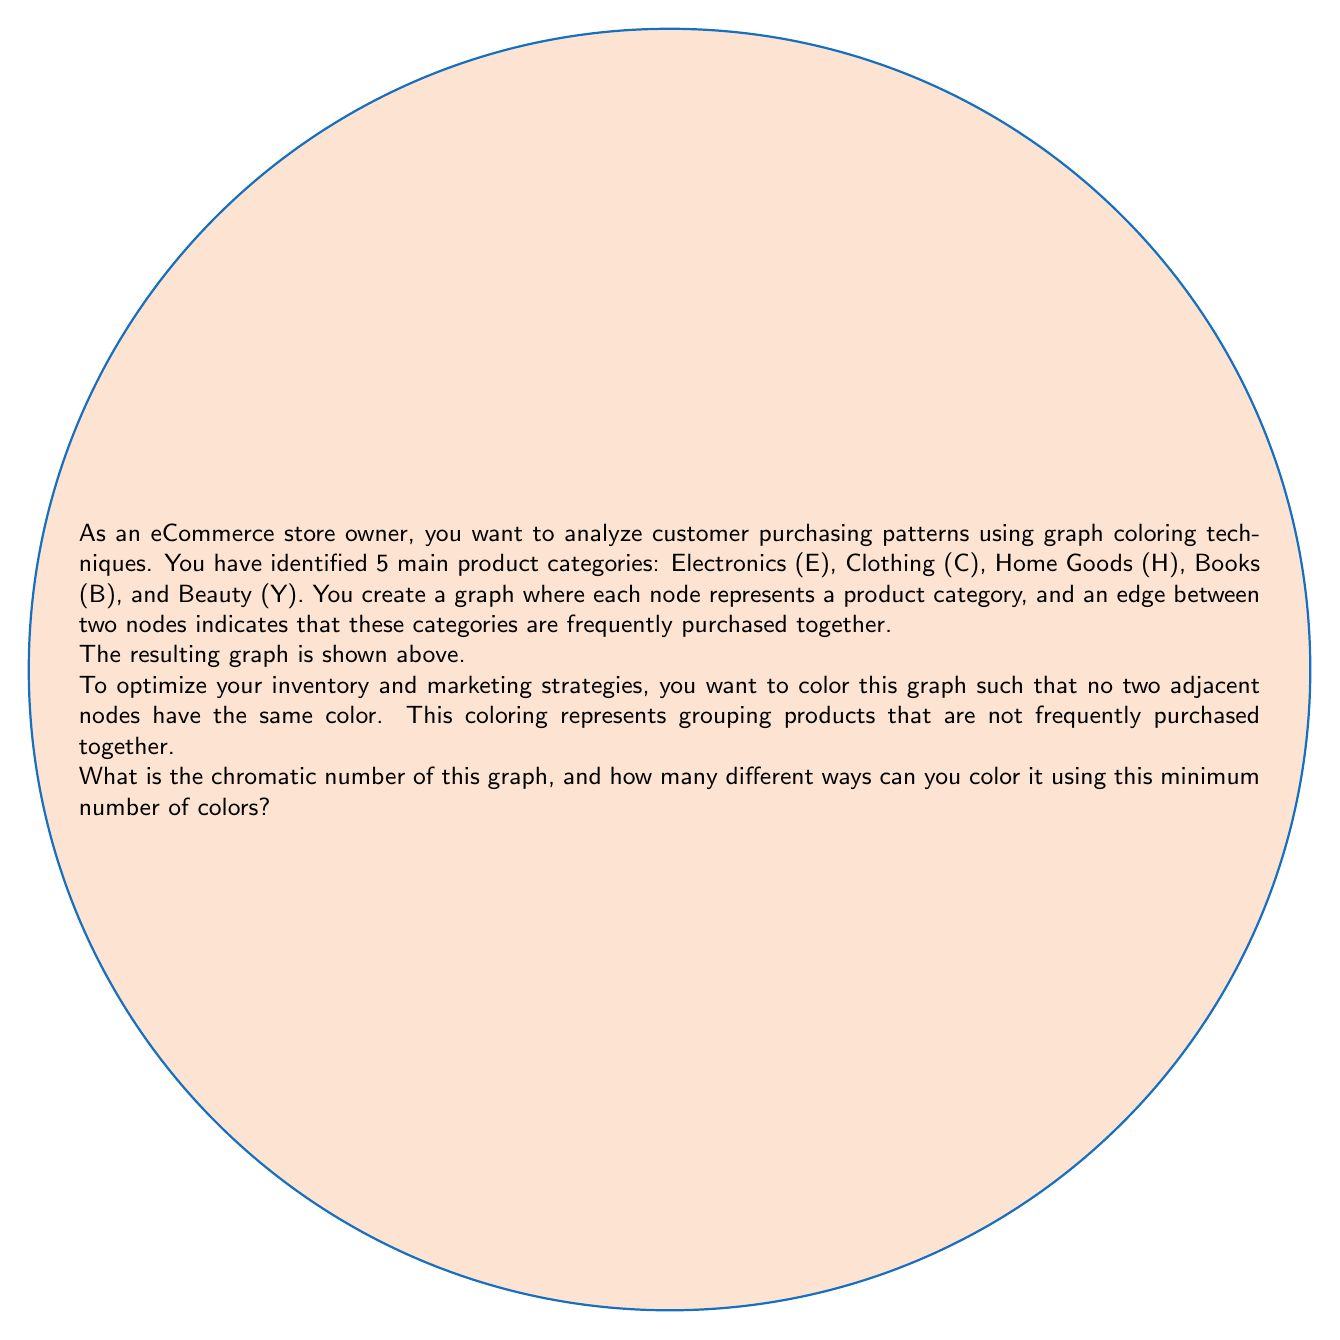Can you solve this math problem? Let's approach this step-by-step:

1) First, we need to determine the chromatic number of the graph. The chromatic number is the minimum number of colors needed to color the graph such that no two adjacent vertices have the same color.

2) Looking at the graph, we can see that it forms a complete graph K5 (a graph where every pair of vertices is connected by an edge), minus one edge (between E and B).

3) For a complete graph Kn, the chromatic number is always n. However, since we're missing one edge, we might be able to use fewer colors.

4) Let's try to color the graph:
   - Start with vertex E: color it red
   - C is adjacent to E, so color it blue
   - H is adjacent to both E and C, so color it green
   - B is adjacent to C and H, but not E. We can color it red
   - Y is adjacent to E, H, and B, so we need a new color: yellow

5) We've used 4 colors, and it's impossible to use fewer because ECHB form a complete subgraph K4.

6) Therefore, the chromatic number of this graph is 4.

7) Now, for the second part of the question, we need to count how many ways we can color this graph using 4 colors.

8) We can use the following logic:
   - We have 4 choices for the first vertex
   - 3 choices for the second vertex
   - 2 choices for the third vertex
   - 1 choice for the fourth vertex
   - The last vertex must be colored with the remaining color

9) This gives us 4! = 24 ways to assign 4 colors to 5 vertices.

10) However, the order of colors doesn't matter. For example, (Red, Blue, Green, Yellow) is the same as (Blue, Red, Yellow, Green). We need to divide by the number of ways to arrange 4 colors, which is also 4!.

11) Therefore, the number of distinct 4-colorings is:

    $$\frac{4!}{4!} = 1$$

Thus, there is only one unique way to 4-color this graph, up to permutation of colors.
Answer: Chromatic number: 4; Unique colorings: 1 